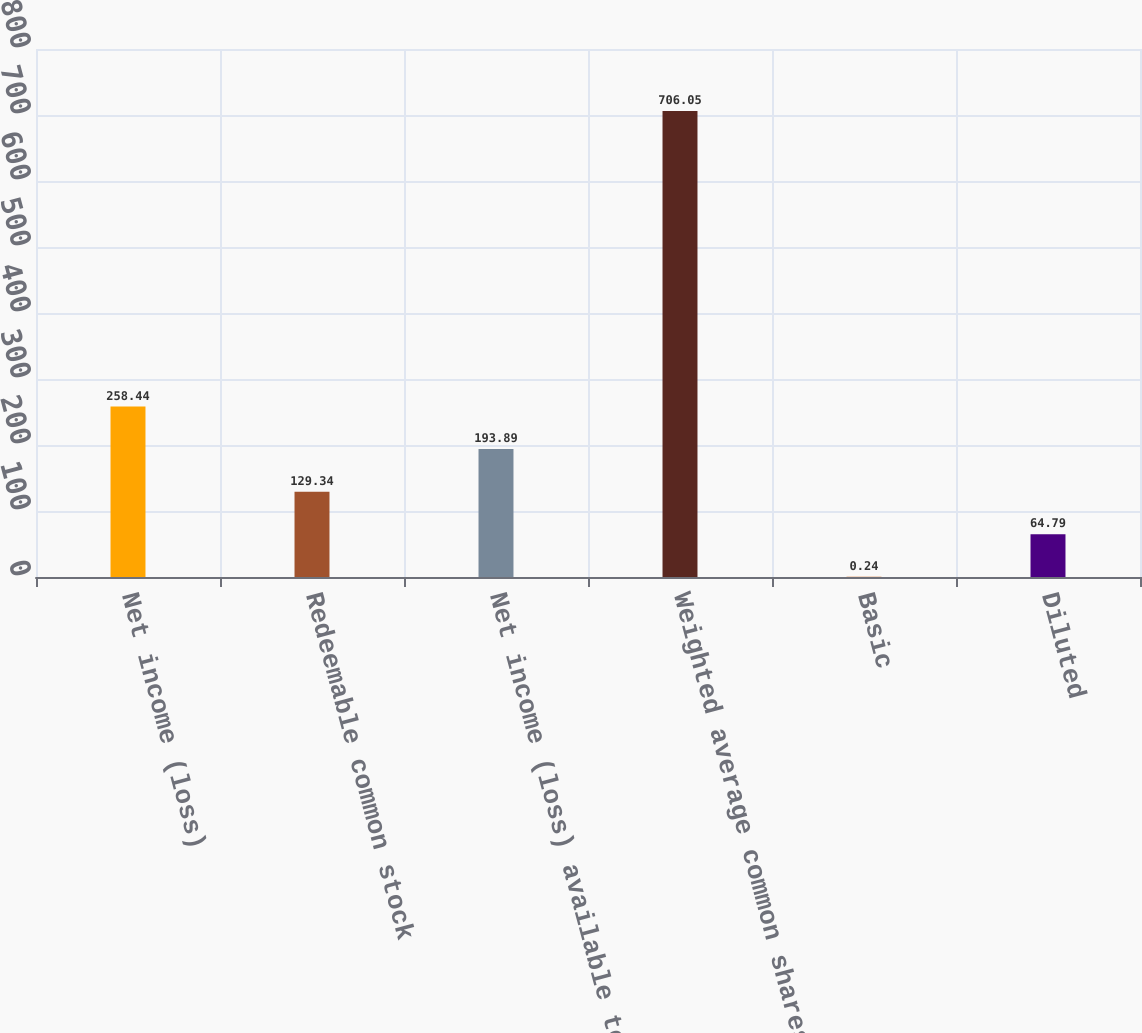Convert chart to OTSL. <chart><loc_0><loc_0><loc_500><loc_500><bar_chart><fcel>Net income (loss)<fcel>Redeemable common stock<fcel>Net income (loss) available to<fcel>Weighted average common shares<fcel>Basic<fcel>Diluted<nl><fcel>258.44<fcel>129.34<fcel>193.89<fcel>706.05<fcel>0.24<fcel>64.79<nl></chart> 